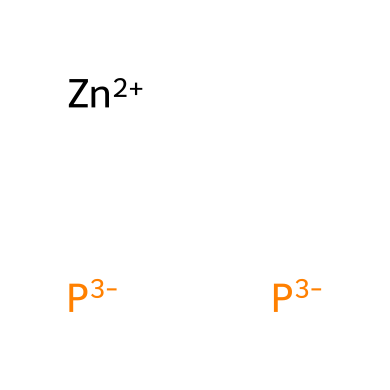What is the central metal atom in zinc phosphide? The chemical structure includes the notation [Zn+2], indicating that the central atom is zinc.
Answer: zinc How many phosphorus atoms are present in zinc phosphide? The structure includes two instances of [P-3], which means there are two phosphorus atoms in the compound.
Answer: 2 What oxidation state is zinc in this compound? The notation [Zn+2] specifies that zinc is in the +2 oxidation state.
Answer: +2 What type of chemical is zinc phosphide? Zinc phosphide is classified as a rodenticide based on its intended use for controlling wild boar and other rodents.
Answer: rodenticide What charge does each phosphorus atom carry in zinc phosphide? The chemical notation shows that each phosphorus atom is represented as [P-3], indicating that each carries a -3 charge.
Answer: -3 How many total atoms are there in zinc phosphide? There is 1 zinc atom and 2 phosphorus atoms, totaling 3 atoms in the formula.
Answer: 3 